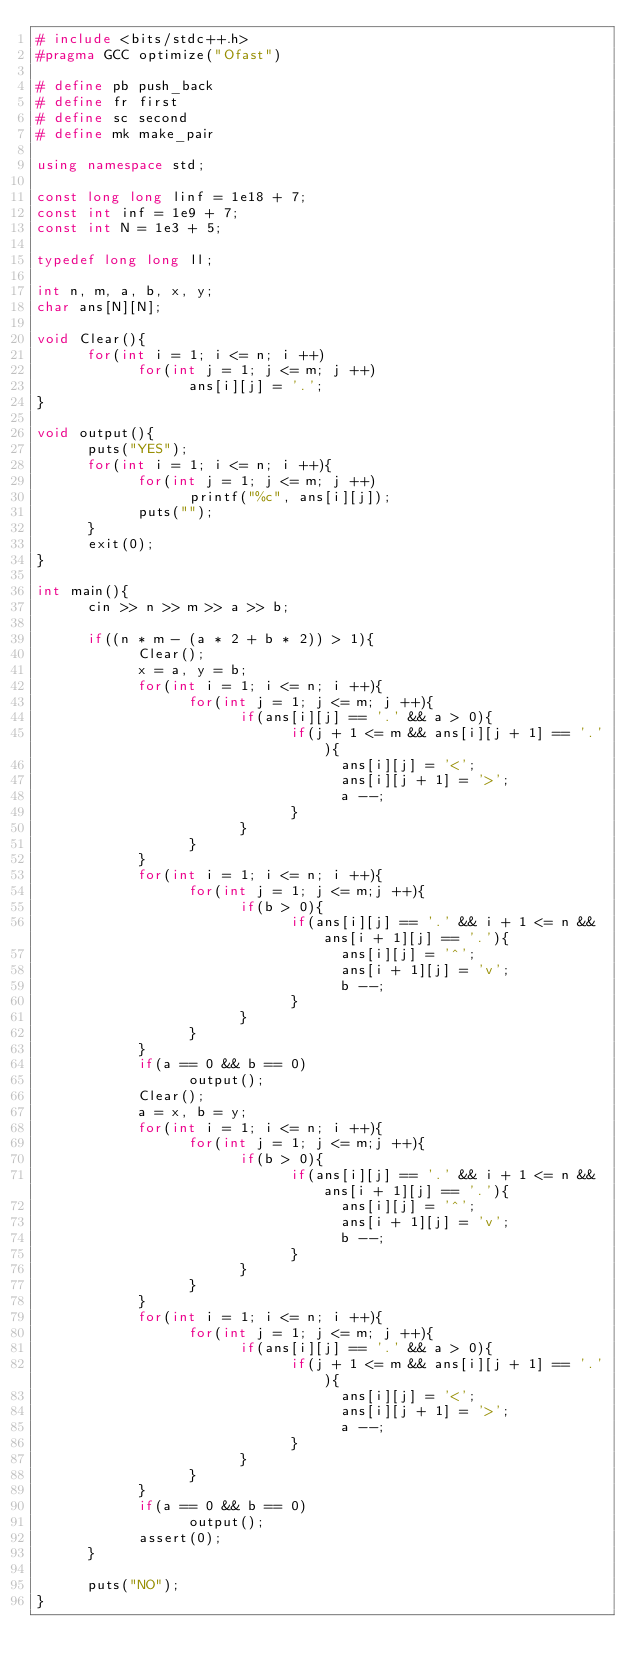<code> <loc_0><loc_0><loc_500><loc_500><_C++_># include <bits/stdc++.h>
#pragma GCC optimize("Ofast")

# define pb push_back
# define fr first
# define sc second
# define mk make_pair

using namespace std;

const long long linf = 1e18 + 7;
const int inf = 1e9 + 7;
const int N = 1e3 + 5;

typedef long long ll;

int n, m, a, b, x, y;
char ans[N][N];

void Clear(){
      for(int i = 1; i <= n; i ++)
            for(int j = 1; j <= m; j ++)
                  ans[i][j] = '.';
}

void output(){
      puts("YES");
      for(int i = 1; i <= n; i ++){
            for(int j = 1; j <= m; j ++)
                  printf("%c", ans[i][j]);
            puts("");
      }
      exit(0);
}

int main(){
      cin >> n >> m >> a >> b;

      if((n * m - (a * 2 + b * 2)) > 1){
            Clear();
            x = a, y = b;
            for(int i = 1; i <= n; i ++){
                  for(int j = 1; j <= m; j ++){
                        if(ans[i][j] == '.' && a > 0){
                              if(j + 1 <= m && ans[i][j + 1] == '.'){
                                    ans[i][j] = '<';
                                    ans[i][j + 1] = '>';
                                    a --;
                              }
                        }
                  }
            }
            for(int i = 1; i <= n; i ++){
                  for(int j = 1; j <= m;j ++){
                        if(b > 0){
                              if(ans[i][j] == '.' && i + 1 <= n && ans[i + 1][j] == '.'){
                                    ans[i][j] = '^';
                                    ans[i + 1][j] = 'v';
                                    b --;
                              }
                        }
                  }
            }
            if(a == 0 && b == 0)
                  output();
            Clear();
            a = x, b = y;
            for(int i = 1; i <= n; i ++){
                  for(int j = 1; j <= m;j ++){
                        if(b > 0){
                              if(ans[i][j] == '.' && i + 1 <= n && ans[i + 1][j] == '.'){
                                    ans[i][j] = '^';
                                    ans[i + 1][j] = 'v';
                                    b --;
                              }
                        }
                  }
            }
            for(int i = 1; i <= n; i ++){
                  for(int j = 1; j <= m; j ++){
                        if(ans[i][j] == '.' && a > 0){
                              if(j + 1 <= m && ans[i][j + 1] == '.'){
                                    ans[i][j] = '<';
                                    ans[i][j + 1] = '>';
                                    a --;
                              }
                        }
                  }
            }
            if(a == 0 && b == 0)
                  output();
            assert(0);
      }

      puts("NO");
}
</code> 